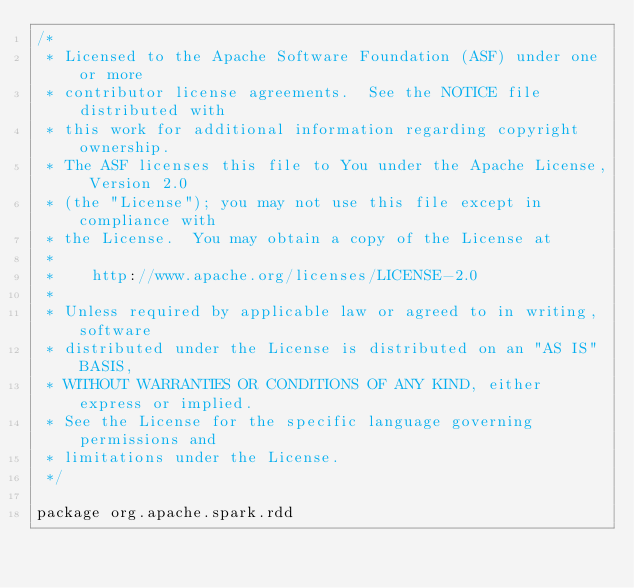Convert code to text. <code><loc_0><loc_0><loc_500><loc_500><_Scala_>/*
 * Licensed to the Apache Software Foundation (ASF) under one or more
 * contributor license agreements.  See the NOTICE file distributed with
 * this work for additional information regarding copyright ownership.
 * The ASF licenses this file to You under the Apache License, Version 2.0
 * (the "License"); you may not use this file except in compliance with
 * the License.  You may obtain a copy of the License at
 *
 *    http://www.apache.org/licenses/LICENSE-2.0
 *
 * Unless required by applicable law or agreed to in writing, software
 * distributed under the License is distributed on an "AS IS" BASIS,
 * WITHOUT WARRANTIES OR CONDITIONS OF ANY KIND, either express or implied.
 * See the License for the specific language governing permissions and
 * limitations under the License.
 */

package org.apache.spark.rdd
</code> 